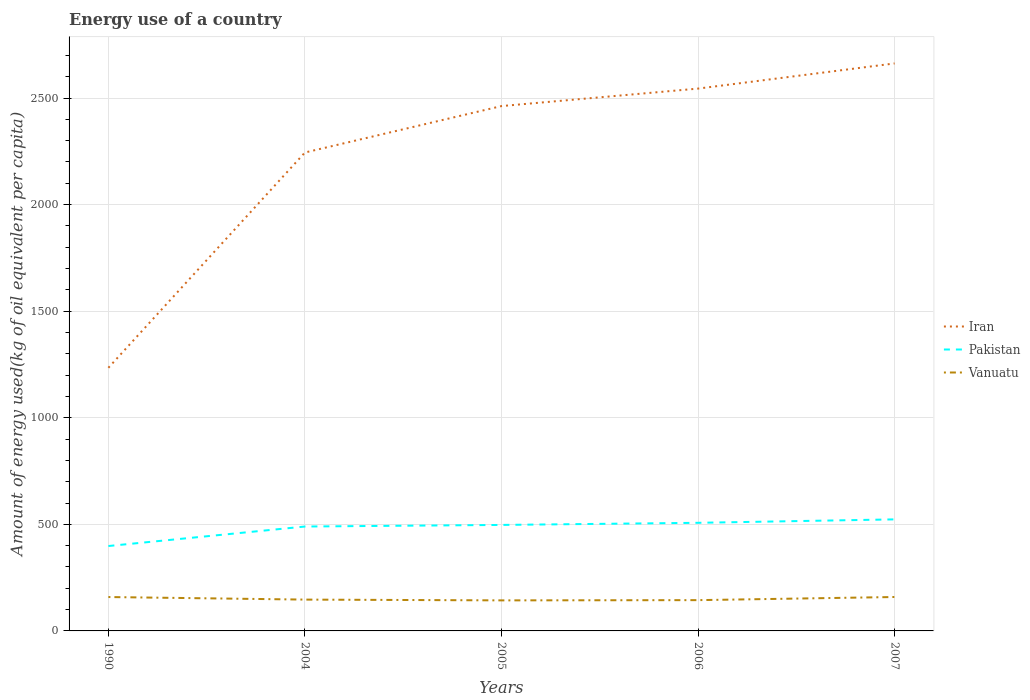How many different coloured lines are there?
Give a very brief answer. 3. Does the line corresponding to Iran intersect with the line corresponding to Vanuatu?
Keep it short and to the point. No. Across all years, what is the maximum amount of energy used in in Iran?
Your answer should be very brief. 1234.42. What is the total amount of energy used in in Pakistan in the graph?
Provide a succinct answer. -7.48. What is the difference between the highest and the second highest amount of energy used in in Pakistan?
Make the answer very short. 124.99. How many lines are there?
Ensure brevity in your answer.  3. How many years are there in the graph?
Your response must be concise. 5. Are the values on the major ticks of Y-axis written in scientific E-notation?
Your response must be concise. No. Does the graph contain any zero values?
Ensure brevity in your answer.  No. How are the legend labels stacked?
Provide a succinct answer. Vertical. What is the title of the graph?
Keep it short and to the point. Energy use of a country. Does "Europe(all income levels)" appear as one of the legend labels in the graph?
Ensure brevity in your answer.  No. What is the label or title of the Y-axis?
Make the answer very short. Amount of energy used(kg of oil equivalent per capita). What is the Amount of energy used(kg of oil equivalent per capita) in Iran in 1990?
Offer a terse response. 1234.42. What is the Amount of energy used(kg of oil equivalent per capita) in Pakistan in 1990?
Give a very brief answer. 398.27. What is the Amount of energy used(kg of oil equivalent per capita) of Vanuatu in 1990?
Ensure brevity in your answer.  159. What is the Amount of energy used(kg of oil equivalent per capita) in Iran in 2004?
Offer a terse response. 2244.38. What is the Amount of energy used(kg of oil equivalent per capita) in Pakistan in 2004?
Offer a terse response. 489.76. What is the Amount of energy used(kg of oil equivalent per capita) of Vanuatu in 2004?
Make the answer very short. 146.96. What is the Amount of energy used(kg of oil equivalent per capita) in Iran in 2005?
Keep it short and to the point. 2462.22. What is the Amount of energy used(kg of oil equivalent per capita) of Pakistan in 2005?
Provide a short and direct response. 497.24. What is the Amount of energy used(kg of oil equivalent per capita) in Vanuatu in 2005?
Provide a succinct answer. 143.28. What is the Amount of energy used(kg of oil equivalent per capita) of Iran in 2006?
Your answer should be very brief. 2544.22. What is the Amount of energy used(kg of oil equivalent per capita) of Pakistan in 2006?
Give a very brief answer. 507.2. What is the Amount of energy used(kg of oil equivalent per capita) of Vanuatu in 2006?
Your answer should be very brief. 144.43. What is the Amount of energy used(kg of oil equivalent per capita) of Iran in 2007?
Offer a terse response. 2662.29. What is the Amount of energy used(kg of oil equivalent per capita) of Pakistan in 2007?
Your answer should be compact. 523.27. What is the Amount of energy used(kg of oil equivalent per capita) of Vanuatu in 2007?
Your answer should be very brief. 159.12. Across all years, what is the maximum Amount of energy used(kg of oil equivalent per capita) of Iran?
Make the answer very short. 2662.29. Across all years, what is the maximum Amount of energy used(kg of oil equivalent per capita) of Pakistan?
Provide a succinct answer. 523.27. Across all years, what is the maximum Amount of energy used(kg of oil equivalent per capita) in Vanuatu?
Your answer should be compact. 159.12. Across all years, what is the minimum Amount of energy used(kg of oil equivalent per capita) of Iran?
Make the answer very short. 1234.42. Across all years, what is the minimum Amount of energy used(kg of oil equivalent per capita) in Pakistan?
Keep it short and to the point. 398.27. Across all years, what is the minimum Amount of energy used(kg of oil equivalent per capita) in Vanuatu?
Give a very brief answer. 143.28. What is the total Amount of energy used(kg of oil equivalent per capita) in Iran in the graph?
Give a very brief answer. 1.11e+04. What is the total Amount of energy used(kg of oil equivalent per capita) of Pakistan in the graph?
Give a very brief answer. 2415.74. What is the total Amount of energy used(kg of oil equivalent per capita) in Vanuatu in the graph?
Keep it short and to the point. 752.79. What is the difference between the Amount of energy used(kg of oil equivalent per capita) in Iran in 1990 and that in 2004?
Make the answer very short. -1009.95. What is the difference between the Amount of energy used(kg of oil equivalent per capita) in Pakistan in 1990 and that in 2004?
Ensure brevity in your answer.  -91.49. What is the difference between the Amount of energy used(kg of oil equivalent per capita) in Vanuatu in 1990 and that in 2004?
Provide a short and direct response. 12.04. What is the difference between the Amount of energy used(kg of oil equivalent per capita) of Iran in 1990 and that in 2005?
Provide a succinct answer. -1227.8. What is the difference between the Amount of energy used(kg of oil equivalent per capita) in Pakistan in 1990 and that in 2005?
Ensure brevity in your answer.  -98.97. What is the difference between the Amount of energy used(kg of oil equivalent per capita) in Vanuatu in 1990 and that in 2005?
Provide a short and direct response. 15.71. What is the difference between the Amount of energy used(kg of oil equivalent per capita) of Iran in 1990 and that in 2006?
Provide a short and direct response. -1309.8. What is the difference between the Amount of energy used(kg of oil equivalent per capita) of Pakistan in 1990 and that in 2006?
Make the answer very short. -108.93. What is the difference between the Amount of energy used(kg of oil equivalent per capita) in Vanuatu in 1990 and that in 2006?
Ensure brevity in your answer.  14.56. What is the difference between the Amount of energy used(kg of oil equivalent per capita) in Iran in 1990 and that in 2007?
Offer a terse response. -1427.86. What is the difference between the Amount of energy used(kg of oil equivalent per capita) of Pakistan in 1990 and that in 2007?
Provide a succinct answer. -124.99. What is the difference between the Amount of energy used(kg of oil equivalent per capita) in Vanuatu in 1990 and that in 2007?
Make the answer very short. -0.13. What is the difference between the Amount of energy used(kg of oil equivalent per capita) in Iran in 2004 and that in 2005?
Your answer should be very brief. -217.84. What is the difference between the Amount of energy used(kg of oil equivalent per capita) in Pakistan in 2004 and that in 2005?
Keep it short and to the point. -7.48. What is the difference between the Amount of energy used(kg of oil equivalent per capita) in Vanuatu in 2004 and that in 2005?
Offer a terse response. 3.67. What is the difference between the Amount of energy used(kg of oil equivalent per capita) of Iran in 2004 and that in 2006?
Your answer should be compact. -299.84. What is the difference between the Amount of energy used(kg of oil equivalent per capita) in Pakistan in 2004 and that in 2006?
Your answer should be compact. -17.44. What is the difference between the Amount of energy used(kg of oil equivalent per capita) of Vanuatu in 2004 and that in 2006?
Make the answer very short. 2.52. What is the difference between the Amount of energy used(kg of oil equivalent per capita) in Iran in 2004 and that in 2007?
Provide a succinct answer. -417.91. What is the difference between the Amount of energy used(kg of oil equivalent per capita) in Pakistan in 2004 and that in 2007?
Give a very brief answer. -33.51. What is the difference between the Amount of energy used(kg of oil equivalent per capita) in Vanuatu in 2004 and that in 2007?
Keep it short and to the point. -12.17. What is the difference between the Amount of energy used(kg of oil equivalent per capita) in Iran in 2005 and that in 2006?
Ensure brevity in your answer.  -82. What is the difference between the Amount of energy used(kg of oil equivalent per capita) in Pakistan in 2005 and that in 2006?
Keep it short and to the point. -9.96. What is the difference between the Amount of energy used(kg of oil equivalent per capita) of Vanuatu in 2005 and that in 2006?
Provide a short and direct response. -1.15. What is the difference between the Amount of energy used(kg of oil equivalent per capita) in Iran in 2005 and that in 2007?
Provide a short and direct response. -200.07. What is the difference between the Amount of energy used(kg of oil equivalent per capita) in Pakistan in 2005 and that in 2007?
Your answer should be compact. -26.03. What is the difference between the Amount of energy used(kg of oil equivalent per capita) in Vanuatu in 2005 and that in 2007?
Your response must be concise. -15.84. What is the difference between the Amount of energy used(kg of oil equivalent per capita) in Iran in 2006 and that in 2007?
Offer a very short reply. -118.06. What is the difference between the Amount of energy used(kg of oil equivalent per capita) of Pakistan in 2006 and that in 2007?
Keep it short and to the point. -16.07. What is the difference between the Amount of energy used(kg of oil equivalent per capita) of Vanuatu in 2006 and that in 2007?
Offer a very short reply. -14.69. What is the difference between the Amount of energy used(kg of oil equivalent per capita) of Iran in 1990 and the Amount of energy used(kg of oil equivalent per capita) of Pakistan in 2004?
Keep it short and to the point. 744.66. What is the difference between the Amount of energy used(kg of oil equivalent per capita) in Iran in 1990 and the Amount of energy used(kg of oil equivalent per capita) in Vanuatu in 2004?
Provide a short and direct response. 1087.47. What is the difference between the Amount of energy used(kg of oil equivalent per capita) in Pakistan in 1990 and the Amount of energy used(kg of oil equivalent per capita) in Vanuatu in 2004?
Your answer should be compact. 251.32. What is the difference between the Amount of energy used(kg of oil equivalent per capita) of Iran in 1990 and the Amount of energy used(kg of oil equivalent per capita) of Pakistan in 2005?
Give a very brief answer. 737.18. What is the difference between the Amount of energy used(kg of oil equivalent per capita) in Iran in 1990 and the Amount of energy used(kg of oil equivalent per capita) in Vanuatu in 2005?
Provide a short and direct response. 1091.14. What is the difference between the Amount of energy used(kg of oil equivalent per capita) in Pakistan in 1990 and the Amount of energy used(kg of oil equivalent per capita) in Vanuatu in 2005?
Your response must be concise. 254.99. What is the difference between the Amount of energy used(kg of oil equivalent per capita) of Iran in 1990 and the Amount of energy used(kg of oil equivalent per capita) of Pakistan in 2006?
Keep it short and to the point. 727.23. What is the difference between the Amount of energy used(kg of oil equivalent per capita) of Iran in 1990 and the Amount of energy used(kg of oil equivalent per capita) of Vanuatu in 2006?
Give a very brief answer. 1089.99. What is the difference between the Amount of energy used(kg of oil equivalent per capita) in Pakistan in 1990 and the Amount of energy used(kg of oil equivalent per capita) in Vanuatu in 2006?
Keep it short and to the point. 253.84. What is the difference between the Amount of energy used(kg of oil equivalent per capita) in Iran in 1990 and the Amount of energy used(kg of oil equivalent per capita) in Pakistan in 2007?
Your response must be concise. 711.16. What is the difference between the Amount of energy used(kg of oil equivalent per capita) in Iran in 1990 and the Amount of energy used(kg of oil equivalent per capita) in Vanuatu in 2007?
Make the answer very short. 1075.3. What is the difference between the Amount of energy used(kg of oil equivalent per capita) of Pakistan in 1990 and the Amount of energy used(kg of oil equivalent per capita) of Vanuatu in 2007?
Your answer should be compact. 239.15. What is the difference between the Amount of energy used(kg of oil equivalent per capita) in Iran in 2004 and the Amount of energy used(kg of oil equivalent per capita) in Pakistan in 2005?
Give a very brief answer. 1747.14. What is the difference between the Amount of energy used(kg of oil equivalent per capita) of Iran in 2004 and the Amount of energy used(kg of oil equivalent per capita) of Vanuatu in 2005?
Provide a succinct answer. 2101.09. What is the difference between the Amount of energy used(kg of oil equivalent per capita) of Pakistan in 2004 and the Amount of energy used(kg of oil equivalent per capita) of Vanuatu in 2005?
Give a very brief answer. 346.48. What is the difference between the Amount of energy used(kg of oil equivalent per capita) in Iran in 2004 and the Amount of energy used(kg of oil equivalent per capita) in Pakistan in 2006?
Your response must be concise. 1737.18. What is the difference between the Amount of energy used(kg of oil equivalent per capita) of Iran in 2004 and the Amount of energy used(kg of oil equivalent per capita) of Vanuatu in 2006?
Make the answer very short. 2099.95. What is the difference between the Amount of energy used(kg of oil equivalent per capita) in Pakistan in 2004 and the Amount of energy used(kg of oil equivalent per capita) in Vanuatu in 2006?
Provide a succinct answer. 345.33. What is the difference between the Amount of energy used(kg of oil equivalent per capita) in Iran in 2004 and the Amount of energy used(kg of oil equivalent per capita) in Pakistan in 2007?
Offer a very short reply. 1721.11. What is the difference between the Amount of energy used(kg of oil equivalent per capita) of Iran in 2004 and the Amount of energy used(kg of oil equivalent per capita) of Vanuatu in 2007?
Give a very brief answer. 2085.26. What is the difference between the Amount of energy used(kg of oil equivalent per capita) in Pakistan in 2004 and the Amount of energy used(kg of oil equivalent per capita) in Vanuatu in 2007?
Make the answer very short. 330.64. What is the difference between the Amount of energy used(kg of oil equivalent per capita) of Iran in 2005 and the Amount of energy used(kg of oil equivalent per capita) of Pakistan in 2006?
Offer a very short reply. 1955.02. What is the difference between the Amount of energy used(kg of oil equivalent per capita) in Iran in 2005 and the Amount of energy used(kg of oil equivalent per capita) in Vanuatu in 2006?
Make the answer very short. 2317.79. What is the difference between the Amount of energy used(kg of oil equivalent per capita) in Pakistan in 2005 and the Amount of energy used(kg of oil equivalent per capita) in Vanuatu in 2006?
Your answer should be compact. 352.81. What is the difference between the Amount of energy used(kg of oil equivalent per capita) of Iran in 2005 and the Amount of energy used(kg of oil equivalent per capita) of Pakistan in 2007?
Give a very brief answer. 1938.95. What is the difference between the Amount of energy used(kg of oil equivalent per capita) of Iran in 2005 and the Amount of energy used(kg of oil equivalent per capita) of Vanuatu in 2007?
Keep it short and to the point. 2303.1. What is the difference between the Amount of energy used(kg of oil equivalent per capita) of Pakistan in 2005 and the Amount of energy used(kg of oil equivalent per capita) of Vanuatu in 2007?
Provide a short and direct response. 338.12. What is the difference between the Amount of energy used(kg of oil equivalent per capita) of Iran in 2006 and the Amount of energy used(kg of oil equivalent per capita) of Pakistan in 2007?
Your answer should be compact. 2020.95. What is the difference between the Amount of energy used(kg of oil equivalent per capita) in Iran in 2006 and the Amount of energy used(kg of oil equivalent per capita) in Vanuatu in 2007?
Ensure brevity in your answer.  2385.1. What is the difference between the Amount of energy used(kg of oil equivalent per capita) of Pakistan in 2006 and the Amount of energy used(kg of oil equivalent per capita) of Vanuatu in 2007?
Provide a short and direct response. 348.08. What is the average Amount of energy used(kg of oil equivalent per capita) of Iran per year?
Offer a terse response. 2229.51. What is the average Amount of energy used(kg of oil equivalent per capita) of Pakistan per year?
Offer a very short reply. 483.15. What is the average Amount of energy used(kg of oil equivalent per capita) of Vanuatu per year?
Your answer should be very brief. 150.56. In the year 1990, what is the difference between the Amount of energy used(kg of oil equivalent per capita) in Iran and Amount of energy used(kg of oil equivalent per capita) in Pakistan?
Offer a very short reply. 836.15. In the year 1990, what is the difference between the Amount of energy used(kg of oil equivalent per capita) in Iran and Amount of energy used(kg of oil equivalent per capita) in Vanuatu?
Offer a terse response. 1075.43. In the year 1990, what is the difference between the Amount of energy used(kg of oil equivalent per capita) in Pakistan and Amount of energy used(kg of oil equivalent per capita) in Vanuatu?
Your response must be concise. 239.28. In the year 2004, what is the difference between the Amount of energy used(kg of oil equivalent per capita) of Iran and Amount of energy used(kg of oil equivalent per capita) of Pakistan?
Your answer should be very brief. 1754.62. In the year 2004, what is the difference between the Amount of energy used(kg of oil equivalent per capita) of Iran and Amount of energy used(kg of oil equivalent per capita) of Vanuatu?
Your response must be concise. 2097.42. In the year 2004, what is the difference between the Amount of energy used(kg of oil equivalent per capita) in Pakistan and Amount of energy used(kg of oil equivalent per capita) in Vanuatu?
Offer a very short reply. 342.81. In the year 2005, what is the difference between the Amount of energy used(kg of oil equivalent per capita) of Iran and Amount of energy used(kg of oil equivalent per capita) of Pakistan?
Offer a terse response. 1964.98. In the year 2005, what is the difference between the Amount of energy used(kg of oil equivalent per capita) of Iran and Amount of energy used(kg of oil equivalent per capita) of Vanuatu?
Provide a succinct answer. 2318.94. In the year 2005, what is the difference between the Amount of energy used(kg of oil equivalent per capita) of Pakistan and Amount of energy used(kg of oil equivalent per capita) of Vanuatu?
Make the answer very short. 353.96. In the year 2006, what is the difference between the Amount of energy used(kg of oil equivalent per capita) in Iran and Amount of energy used(kg of oil equivalent per capita) in Pakistan?
Your answer should be compact. 2037.02. In the year 2006, what is the difference between the Amount of energy used(kg of oil equivalent per capita) of Iran and Amount of energy used(kg of oil equivalent per capita) of Vanuatu?
Your response must be concise. 2399.79. In the year 2006, what is the difference between the Amount of energy used(kg of oil equivalent per capita) in Pakistan and Amount of energy used(kg of oil equivalent per capita) in Vanuatu?
Your answer should be compact. 362.77. In the year 2007, what is the difference between the Amount of energy used(kg of oil equivalent per capita) of Iran and Amount of energy used(kg of oil equivalent per capita) of Pakistan?
Your answer should be very brief. 2139.02. In the year 2007, what is the difference between the Amount of energy used(kg of oil equivalent per capita) of Iran and Amount of energy used(kg of oil equivalent per capita) of Vanuatu?
Provide a short and direct response. 2503.16. In the year 2007, what is the difference between the Amount of energy used(kg of oil equivalent per capita) of Pakistan and Amount of energy used(kg of oil equivalent per capita) of Vanuatu?
Provide a succinct answer. 364.14. What is the ratio of the Amount of energy used(kg of oil equivalent per capita) in Iran in 1990 to that in 2004?
Give a very brief answer. 0.55. What is the ratio of the Amount of energy used(kg of oil equivalent per capita) in Pakistan in 1990 to that in 2004?
Make the answer very short. 0.81. What is the ratio of the Amount of energy used(kg of oil equivalent per capita) of Vanuatu in 1990 to that in 2004?
Provide a succinct answer. 1.08. What is the ratio of the Amount of energy used(kg of oil equivalent per capita) in Iran in 1990 to that in 2005?
Ensure brevity in your answer.  0.5. What is the ratio of the Amount of energy used(kg of oil equivalent per capita) in Pakistan in 1990 to that in 2005?
Keep it short and to the point. 0.8. What is the ratio of the Amount of energy used(kg of oil equivalent per capita) in Vanuatu in 1990 to that in 2005?
Keep it short and to the point. 1.11. What is the ratio of the Amount of energy used(kg of oil equivalent per capita) of Iran in 1990 to that in 2006?
Ensure brevity in your answer.  0.49. What is the ratio of the Amount of energy used(kg of oil equivalent per capita) in Pakistan in 1990 to that in 2006?
Provide a succinct answer. 0.79. What is the ratio of the Amount of energy used(kg of oil equivalent per capita) in Vanuatu in 1990 to that in 2006?
Your answer should be compact. 1.1. What is the ratio of the Amount of energy used(kg of oil equivalent per capita) in Iran in 1990 to that in 2007?
Provide a short and direct response. 0.46. What is the ratio of the Amount of energy used(kg of oil equivalent per capita) of Pakistan in 1990 to that in 2007?
Keep it short and to the point. 0.76. What is the ratio of the Amount of energy used(kg of oil equivalent per capita) of Vanuatu in 1990 to that in 2007?
Your answer should be very brief. 1. What is the ratio of the Amount of energy used(kg of oil equivalent per capita) in Iran in 2004 to that in 2005?
Your response must be concise. 0.91. What is the ratio of the Amount of energy used(kg of oil equivalent per capita) of Pakistan in 2004 to that in 2005?
Provide a succinct answer. 0.98. What is the ratio of the Amount of energy used(kg of oil equivalent per capita) in Vanuatu in 2004 to that in 2005?
Keep it short and to the point. 1.03. What is the ratio of the Amount of energy used(kg of oil equivalent per capita) in Iran in 2004 to that in 2006?
Provide a succinct answer. 0.88. What is the ratio of the Amount of energy used(kg of oil equivalent per capita) in Pakistan in 2004 to that in 2006?
Your answer should be compact. 0.97. What is the ratio of the Amount of energy used(kg of oil equivalent per capita) of Vanuatu in 2004 to that in 2006?
Give a very brief answer. 1.02. What is the ratio of the Amount of energy used(kg of oil equivalent per capita) in Iran in 2004 to that in 2007?
Your answer should be very brief. 0.84. What is the ratio of the Amount of energy used(kg of oil equivalent per capita) in Pakistan in 2004 to that in 2007?
Your answer should be very brief. 0.94. What is the ratio of the Amount of energy used(kg of oil equivalent per capita) of Vanuatu in 2004 to that in 2007?
Your answer should be very brief. 0.92. What is the ratio of the Amount of energy used(kg of oil equivalent per capita) of Iran in 2005 to that in 2006?
Your answer should be very brief. 0.97. What is the ratio of the Amount of energy used(kg of oil equivalent per capita) in Pakistan in 2005 to that in 2006?
Make the answer very short. 0.98. What is the ratio of the Amount of energy used(kg of oil equivalent per capita) of Vanuatu in 2005 to that in 2006?
Provide a short and direct response. 0.99. What is the ratio of the Amount of energy used(kg of oil equivalent per capita) of Iran in 2005 to that in 2007?
Give a very brief answer. 0.92. What is the ratio of the Amount of energy used(kg of oil equivalent per capita) in Pakistan in 2005 to that in 2007?
Your answer should be very brief. 0.95. What is the ratio of the Amount of energy used(kg of oil equivalent per capita) in Vanuatu in 2005 to that in 2007?
Keep it short and to the point. 0.9. What is the ratio of the Amount of energy used(kg of oil equivalent per capita) in Iran in 2006 to that in 2007?
Give a very brief answer. 0.96. What is the ratio of the Amount of energy used(kg of oil equivalent per capita) of Pakistan in 2006 to that in 2007?
Keep it short and to the point. 0.97. What is the ratio of the Amount of energy used(kg of oil equivalent per capita) of Vanuatu in 2006 to that in 2007?
Make the answer very short. 0.91. What is the difference between the highest and the second highest Amount of energy used(kg of oil equivalent per capita) in Iran?
Provide a succinct answer. 118.06. What is the difference between the highest and the second highest Amount of energy used(kg of oil equivalent per capita) of Pakistan?
Offer a very short reply. 16.07. What is the difference between the highest and the second highest Amount of energy used(kg of oil equivalent per capita) of Vanuatu?
Keep it short and to the point. 0.13. What is the difference between the highest and the lowest Amount of energy used(kg of oil equivalent per capita) in Iran?
Give a very brief answer. 1427.86. What is the difference between the highest and the lowest Amount of energy used(kg of oil equivalent per capita) in Pakistan?
Make the answer very short. 124.99. What is the difference between the highest and the lowest Amount of energy used(kg of oil equivalent per capita) in Vanuatu?
Ensure brevity in your answer.  15.84. 